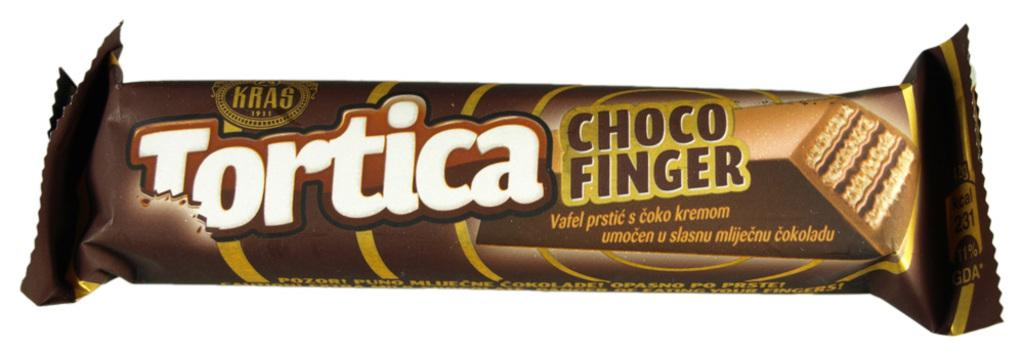What type of candy is in the image? There is a chocolate in the image. What color is the wrapper of the chocolate? The wrapper of the chocolate is brown. What type of grain is being added to the chocolate during the meeting in the image? There is no grain, addition, or meeting present in the image; it only features a chocolate with a brown wrapper. 